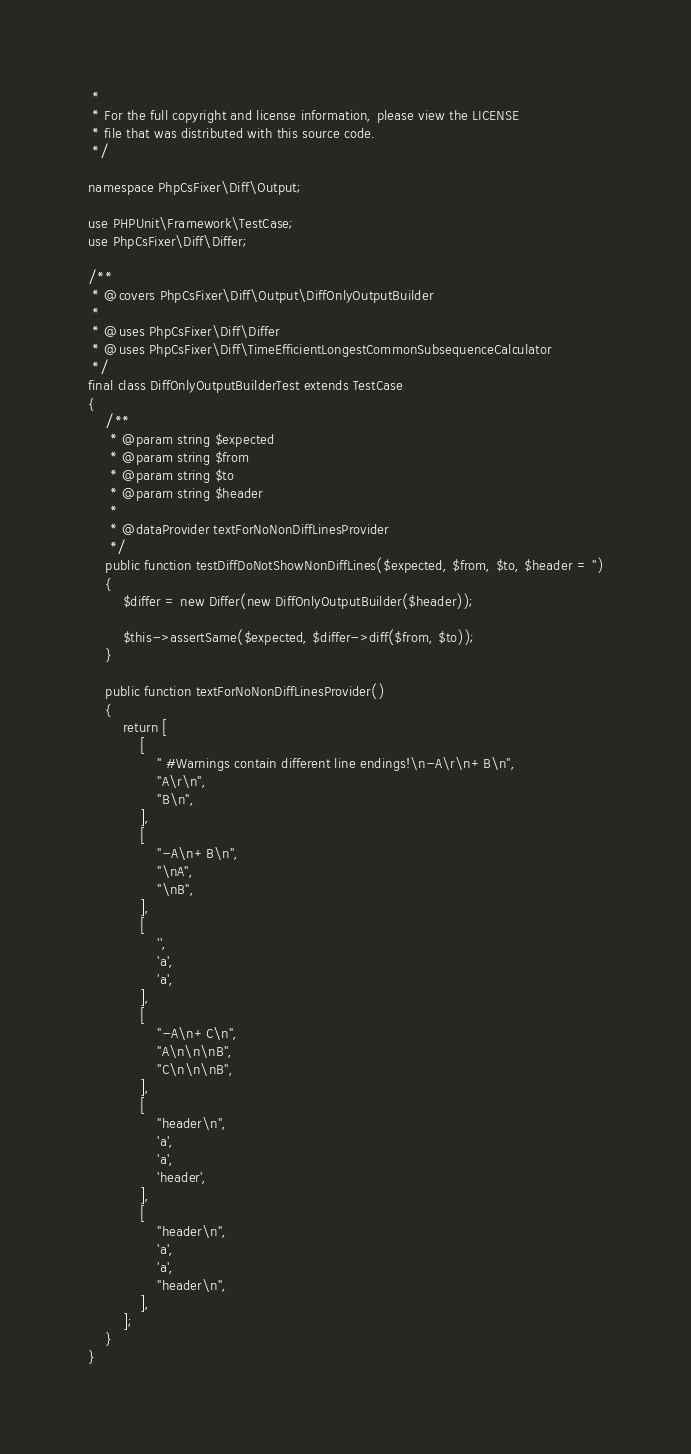Convert code to text. <code><loc_0><loc_0><loc_500><loc_500><_PHP_> *
 * For the full copyright and license information, please view the LICENSE
 * file that was distributed with this source code.
 */

namespace PhpCsFixer\Diff\Output;

use PHPUnit\Framework\TestCase;
use PhpCsFixer\Diff\Differ;

/**
 * @covers PhpCsFixer\Diff\Output\DiffOnlyOutputBuilder
 *
 * @uses PhpCsFixer\Diff\Differ
 * @uses PhpCsFixer\Diff\TimeEfficientLongestCommonSubsequenceCalculator
 */
final class DiffOnlyOutputBuilderTest extends TestCase
{
    /**
     * @param string $expected
     * @param string $from
     * @param string $to
     * @param string $header
     *
     * @dataProvider textForNoNonDiffLinesProvider
     */
    public function testDiffDoNotShowNonDiffLines($expected, $from, $to, $header = '')
    {
        $differ = new Differ(new DiffOnlyOutputBuilder($header));

        $this->assertSame($expected, $differ->diff($from, $to));
    }

    public function textForNoNonDiffLinesProvider()
    {
        return [
            [
                " #Warnings contain different line endings!\n-A\r\n+B\n",
                "A\r\n",
                "B\n",
            ],
            [
                "-A\n+B\n",
                "\nA",
                "\nB",
            ],
            [
                '',
                'a',
                'a',
            ],
            [
                "-A\n+C\n",
                "A\n\n\nB",
                "C\n\n\nB",
            ],
            [
                "header\n",
                'a',
                'a',
                'header',
            ],
            [
                "header\n",
                'a',
                'a',
                "header\n",
            ],
        ];
    }
}
</code> 